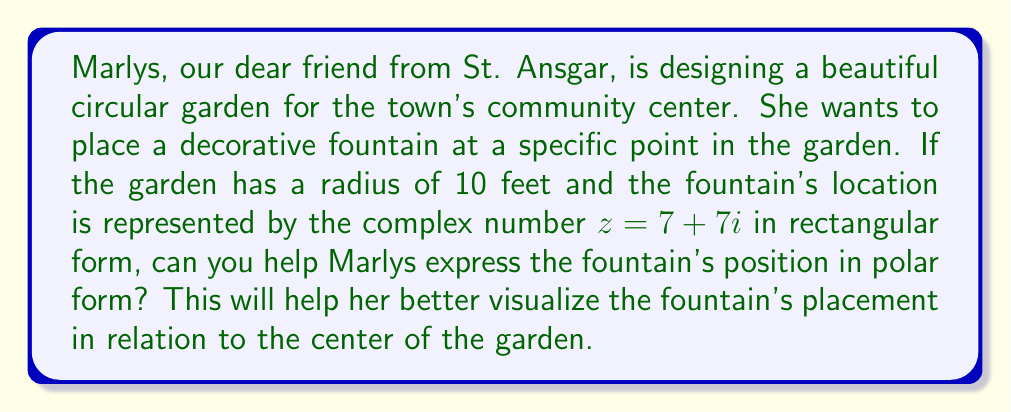Could you help me with this problem? To convert the complex number $z = 7 + 7i$ from rectangular form to polar form, we need to find its modulus (magnitude) and argument (angle). The polar form is expressed as $r(\cos\theta + i\sin\theta)$ or $re^{i\theta}$.

Step 1: Calculate the modulus (r)
$$r = \sqrt{a^2 + b^2} = \sqrt{7^2 + 7^2} = \sqrt{98} = 7\sqrt{2}$$

Step 2: Calculate the argument (θ)
$$\theta = \tan^{-1}\left(\frac{b}{a}\right) = \tan^{-1}\left(\frac{7}{7}\right) = \tan^{-1}(1) = \frac{\pi}{4}$$

Step 3: Express in polar form
$$z = 7\sqrt{2}\left(\cos\frac{\pi}{4} + i\sin\frac{\pi}{4}\right)$$

or

$$z = 7\sqrt{2}e^{i\pi/4}$$

To help Marlys visualize this:
- The fountain is $7\sqrt{2} \approx 9.9$ feet from the center of the garden.
- It's placed at an angle of $\frac{\pi}{4}$ radians or 45° from the positive x-axis.

[asy]
import geometry;

size(200);
draw(circle((0,0),10), blue);
dot((0,0), red);
draw((0,0)--(7,7), green, Arrow);
label("Center", (0,0), SW);
label("Fountain", (7,7), NE);
label("$7\sqrt{2}$", (3.5,3.5), NW);
draw(arc((0,0),2,0,45), red);
label("$\frac{\pi}{4}$", (1.5,0.5), N);
</asy]
Answer: $z = 7\sqrt{2}\left(\cos\frac{\pi}{4} + i\sin\frac{\pi}{4}\right)$ or $z = 7\sqrt{2}e^{i\pi/4}$ 